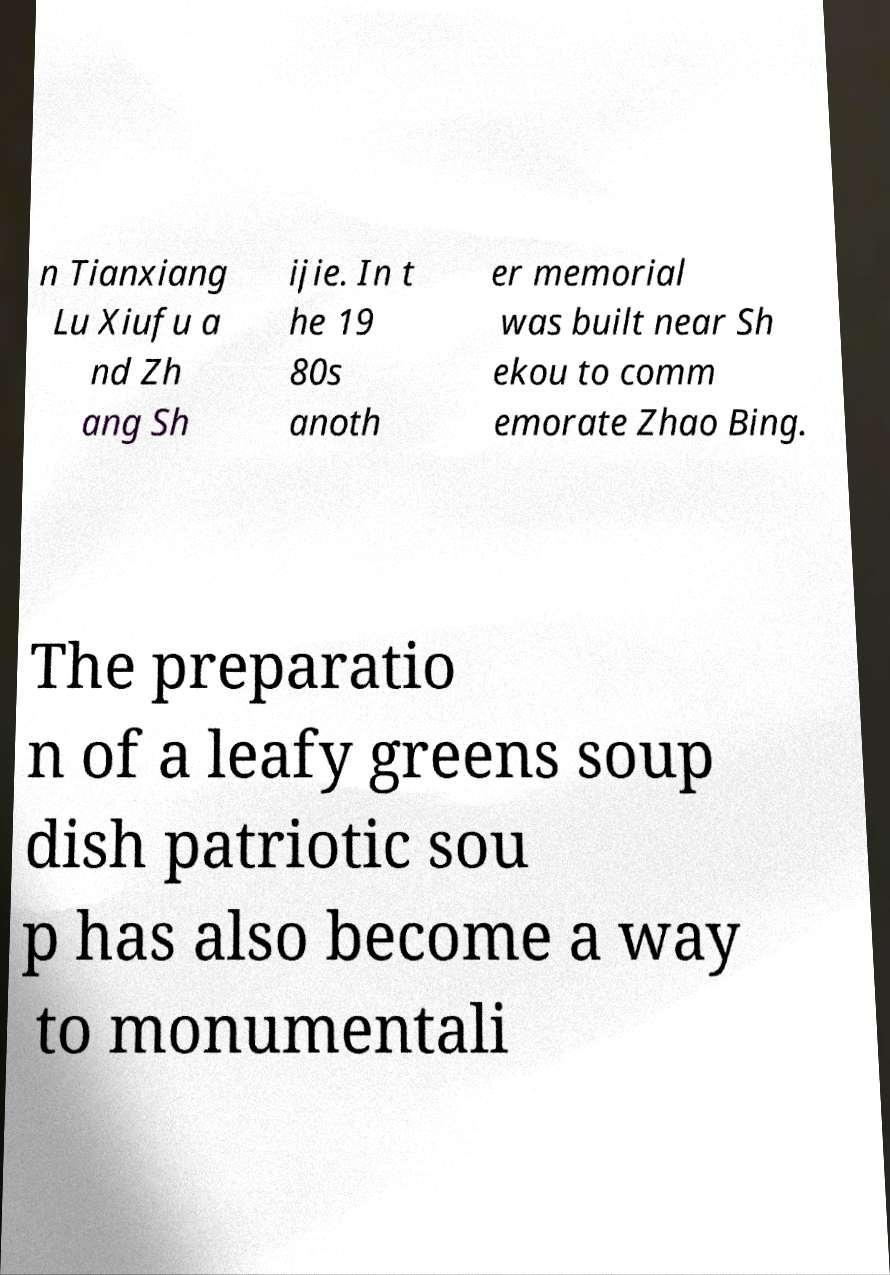What messages or text are displayed in this image? I need them in a readable, typed format. n Tianxiang Lu Xiufu a nd Zh ang Sh ijie. In t he 19 80s anoth er memorial was built near Sh ekou to comm emorate Zhao Bing. The preparatio n of a leafy greens soup dish patriotic sou p has also become a way to monumentali 